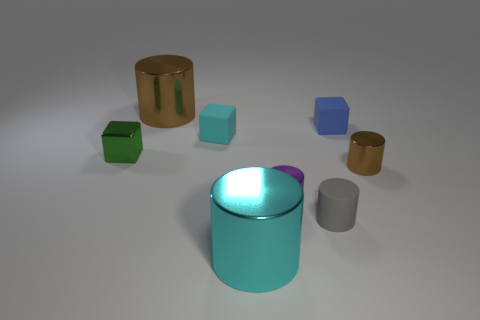Subtract 1 blocks. How many blocks are left? 2 Subtract all purple cylinders. How many cylinders are left? 4 Subtract all small rubber cubes. How many cubes are left? 1 Add 1 large cyan rubber objects. How many objects exist? 9 Subtract all cyan cylinders. Subtract all brown cubes. How many cylinders are left? 4 Subtract all cylinders. How many objects are left? 3 Add 1 small yellow matte cubes. How many small yellow matte cubes exist? 1 Subtract 0 red cubes. How many objects are left? 8 Subtract all tiny blue cubes. Subtract all small cubes. How many objects are left? 4 Add 5 small cylinders. How many small cylinders are left? 8 